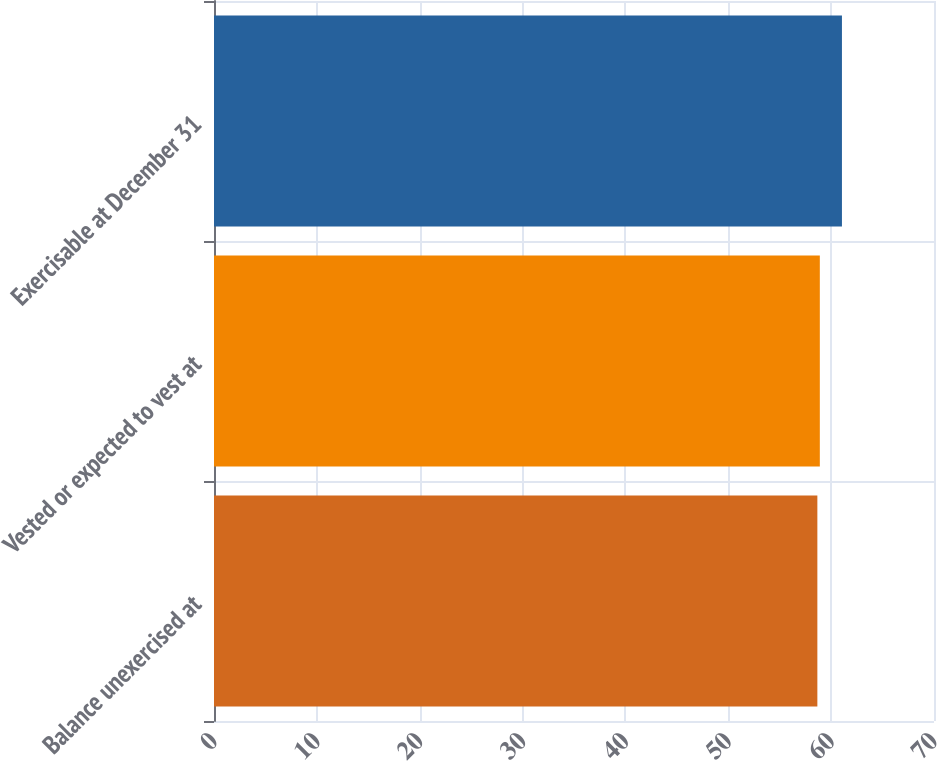<chart> <loc_0><loc_0><loc_500><loc_500><bar_chart><fcel>Balance unexercised at<fcel>Vested or expected to vest at<fcel>Exercisable at December 31<nl><fcel>58.66<fcel>58.9<fcel>61.05<nl></chart> 